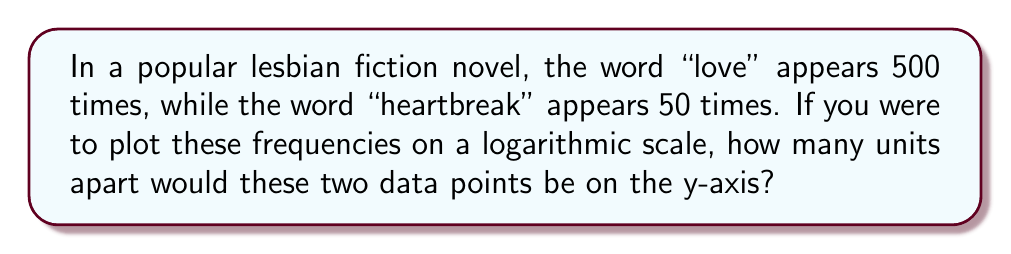Teach me how to tackle this problem. To solve this problem, we need to follow these steps:

1. Calculate the logarithm of each word's frequency.
2. Subtract the smaller logarithm from the larger one.

Let's begin:

1. For "love":
   $\log_{10}(500) = 2.69897$

2. For "heartbreak":
   $\log_{10}(50) = 1.69897$

3. Calculate the difference:
   $2.69897 - 1.69897 = 1$

The difference of 1 in logarithmic scale means that the original values differ by a factor of 10. Indeed, 500 is 10 times greater than 50.

On a logarithmic scale, each unit represents a factor of 10. Therefore, the two data points would be exactly 1 unit apart on the y-axis.
Answer: 1 unit 